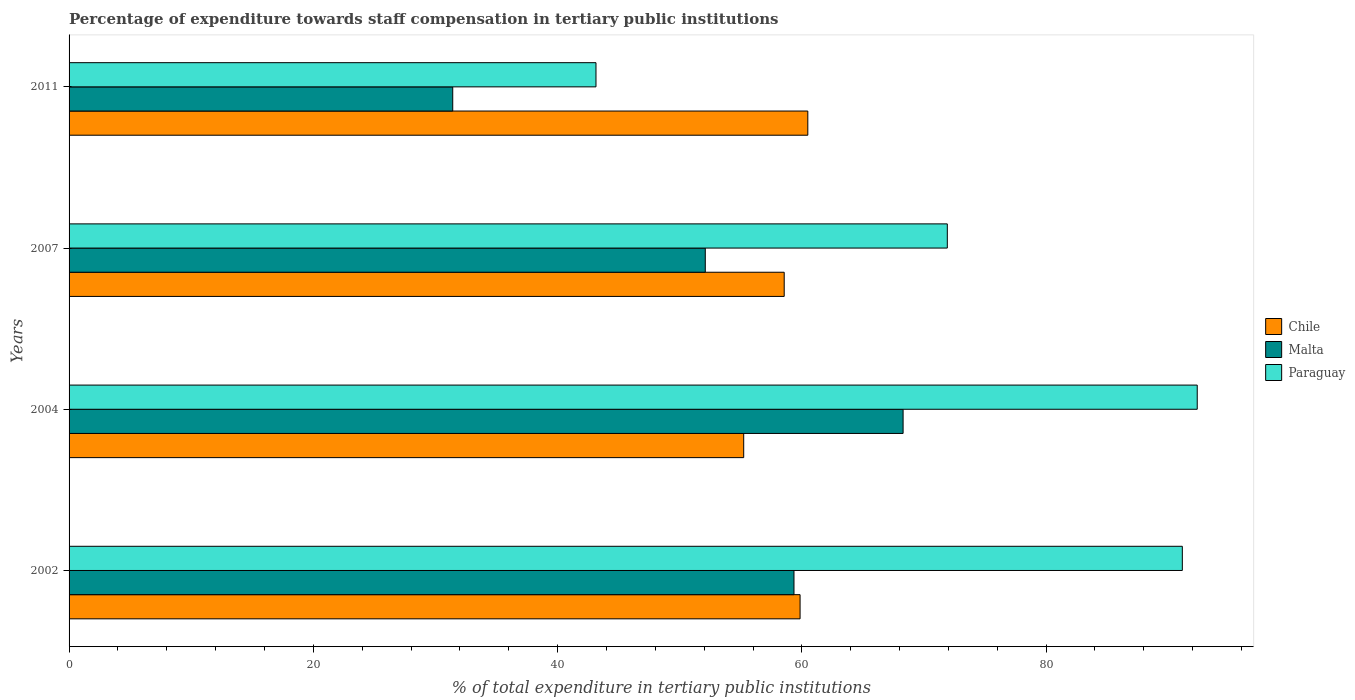How many different coloured bars are there?
Provide a succinct answer. 3. How many groups of bars are there?
Offer a very short reply. 4. Are the number of bars on each tick of the Y-axis equal?
Your response must be concise. Yes. How many bars are there on the 2nd tick from the bottom?
Keep it short and to the point. 3. What is the percentage of expenditure towards staff compensation in Chile in 2011?
Your response must be concise. 60.49. Across all years, what is the maximum percentage of expenditure towards staff compensation in Malta?
Give a very brief answer. 68.29. Across all years, what is the minimum percentage of expenditure towards staff compensation in Chile?
Your response must be concise. 55.24. In which year was the percentage of expenditure towards staff compensation in Paraguay maximum?
Ensure brevity in your answer.  2004. In which year was the percentage of expenditure towards staff compensation in Paraguay minimum?
Give a very brief answer. 2011. What is the total percentage of expenditure towards staff compensation in Chile in the graph?
Give a very brief answer. 234.14. What is the difference between the percentage of expenditure towards staff compensation in Paraguay in 2007 and that in 2011?
Your answer should be compact. 28.77. What is the difference between the percentage of expenditure towards staff compensation in Paraguay in 2004 and the percentage of expenditure towards staff compensation in Chile in 2007?
Offer a very short reply. 33.82. What is the average percentage of expenditure towards staff compensation in Paraguay per year?
Your answer should be compact. 74.64. In the year 2007, what is the difference between the percentage of expenditure towards staff compensation in Chile and percentage of expenditure towards staff compensation in Paraguay?
Make the answer very short. -13.35. What is the ratio of the percentage of expenditure towards staff compensation in Paraguay in 2002 to that in 2011?
Offer a terse response. 2.11. What is the difference between the highest and the second highest percentage of expenditure towards staff compensation in Paraguay?
Provide a short and direct response. 1.22. What is the difference between the highest and the lowest percentage of expenditure towards staff compensation in Malta?
Give a very brief answer. 36.88. In how many years, is the percentage of expenditure towards staff compensation in Paraguay greater than the average percentage of expenditure towards staff compensation in Paraguay taken over all years?
Give a very brief answer. 2. What does the 2nd bar from the top in 2004 represents?
Your answer should be compact. Malta. What does the 2nd bar from the bottom in 2011 represents?
Provide a succinct answer. Malta. Is it the case that in every year, the sum of the percentage of expenditure towards staff compensation in Chile and percentage of expenditure towards staff compensation in Paraguay is greater than the percentage of expenditure towards staff compensation in Malta?
Your response must be concise. Yes. How many bars are there?
Offer a terse response. 12. Are all the bars in the graph horizontal?
Your answer should be compact. Yes. How many years are there in the graph?
Your answer should be very brief. 4. What is the difference between two consecutive major ticks on the X-axis?
Keep it short and to the point. 20. Are the values on the major ticks of X-axis written in scientific E-notation?
Your answer should be very brief. No. Does the graph contain grids?
Your response must be concise. No. Where does the legend appear in the graph?
Your answer should be very brief. Center right. What is the title of the graph?
Offer a very short reply. Percentage of expenditure towards staff compensation in tertiary public institutions. Does "Japan" appear as one of the legend labels in the graph?
Your answer should be compact. No. What is the label or title of the X-axis?
Ensure brevity in your answer.  % of total expenditure in tertiary public institutions. What is the label or title of the Y-axis?
Your answer should be very brief. Years. What is the % of total expenditure in tertiary public institutions of Chile in 2002?
Provide a succinct answer. 59.85. What is the % of total expenditure in tertiary public institutions in Malta in 2002?
Offer a terse response. 59.36. What is the % of total expenditure in tertiary public institutions in Paraguay in 2002?
Make the answer very short. 91.15. What is the % of total expenditure in tertiary public institutions of Chile in 2004?
Your response must be concise. 55.24. What is the % of total expenditure in tertiary public institutions of Malta in 2004?
Your answer should be very brief. 68.29. What is the % of total expenditure in tertiary public institutions in Paraguay in 2004?
Offer a terse response. 92.37. What is the % of total expenditure in tertiary public institutions of Chile in 2007?
Offer a terse response. 58.56. What is the % of total expenditure in tertiary public institutions in Malta in 2007?
Offer a very short reply. 52.09. What is the % of total expenditure in tertiary public institutions of Paraguay in 2007?
Your answer should be compact. 71.91. What is the % of total expenditure in tertiary public institutions of Chile in 2011?
Your answer should be very brief. 60.49. What is the % of total expenditure in tertiary public institutions of Malta in 2011?
Provide a short and direct response. 31.41. What is the % of total expenditure in tertiary public institutions in Paraguay in 2011?
Give a very brief answer. 43.14. Across all years, what is the maximum % of total expenditure in tertiary public institutions of Chile?
Your response must be concise. 60.49. Across all years, what is the maximum % of total expenditure in tertiary public institutions of Malta?
Offer a very short reply. 68.29. Across all years, what is the maximum % of total expenditure in tertiary public institutions in Paraguay?
Your response must be concise. 92.37. Across all years, what is the minimum % of total expenditure in tertiary public institutions in Chile?
Provide a succinct answer. 55.24. Across all years, what is the minimum % of total expenditure in tertiary public institutions of Malta?
Ensure brevity in your answer.  31.41. Across all years, what is the minimum % of total expenditure in tertiary public institutions of Paraguay?
Give a very brief answer. 43.14. What is the total % of total expenditure in tertiary public institutions in Chile in the graph?
Your response must be concise. 234.14. What is the total % of total expenditure in tertiary public institutions in Malta in the graph?
Give a very brief answer. 211.15. What is the total % of total expenditure in tertiary public institutions in Paraguay in the graph?
Ensure brevity in your answer.  298.58. What is the difference between the % of total expenditure in tertiary public institutions in Chile in 2002 and that in 2004?
Provide a short and direct response. 4.62. What is the difference between the % of total expenditure in tertiary public institutions in Malta in 2002 and that in 2004?
Offer a terse response. -8.93. What is the difference between the % of total expenditure in tertiary public institutions of Paraguay in 2002 and that in 2004?
Keep it short and to the point. -1.22. What is the difference between the % of total expenditure in tertiary public institutions in Chile in 2002 and that in 2007?
Keep it short and to the point. 1.3. What is the difference between the % of total expenditure in tertiary public institutions in Malta in 2002 and that in 2007?
Give a very brief answer. 7.26. What is the difference between the % of total expenditure in tertiary public institutions in Paraguay in 2002 and that in 2007?
Provide a succinct answer. 19.24. What is the difference between the % of total expenditure in tertiary public institutions of Chile in 2002 and that in 2011?
Your response must be concise. -0.63. What is the difference between the % of total expenditure in tertiary public institutions of Malta in 2002 and that in 2011?
Your answer should be compact. 27.94. What is the difference between the % of total expenditure in tertiary public institutions in Paraguay in 2002 and that in 2011?
Your response must be concise. 48.01. What is the difference between the % of total expenditure in tertiary public institutions in Chile in 2004 and that in 2007?
Your answer should be compact. -3.32. What is the difference between the % of total expenditure in tertiary public institutions of Malta in 2004 and that in 2007?
Make the answer very short. 16.2. What is the difference between the % of total expenditure in tertiary public institutions in Paraguay in 2004 and that in 2007?
Keep it short and to the point. 20.46. What is the difference between the % of total expenditure in tertiary public institutions of Chile in 2004 and that in 2011?
Keep it short and to the point. -5.25. What is the difference between the % of total expenditure in tertiary public institutions in Malta in 2004 and that in 2011?
Provide a succinct answer. 36.88. What is the difference between the % of total expenditure in tertiary public institutions of Paraguay in 2004 and that in 2011?
Provide a succinct answer. 49.23. What is the difference between the % of total expenditure in tertiary public institutions of Chile in 2007 and that in 2011?
Provide a short and direct response. -1.93. What is the difference between the % of total expenditure in tertiary public institutions of Malta in 2007 and that in 2011?
Your answer should be very brief. 20.68. What is the difference between the % of total expenditure in tertiary public institutions of Paraguay in 2007 and that in 2011?
Keep it short and to the point. 28.77. What is the difference between the % of total expenditure in tertiary public institutions in Chile in 2002 and the % of total expenditure in tertiary public institutions in Malta in 2004?
Make the answer very short. -8.44. What is the difference between the % of total expenditure in tertiary public institutions in Chile in 2002 and the % of total expenditure in tertiary public institutions in Paraguay in 2004?
Your response must be concise. -32.52. What is the difference between the % of total expenditure in tertiary public institutions of Malta in 2002 and the % of total expenditure in tertiary public institutions of Paraguay in 2004?
Your answer should be compact. -33.02. What is the difference between the % of total expenditure in tertiary public institutions of Chile in 2002 and the % of total expenditure in tertiary public institutions of Malta in 2007?
Your answer should be compact. 7.76. What is the difference between the % of total expenditure in tertiary public institutions of Chile in 2002 and the % of total expenditure in tertiary public institutions of Paraguay in 2007?
Offer a very short reply. -12.06. What is the difference between the % of total expenditure in tertiary public institutions of Malta in 2002 and the % of total expenditure in tertiary public institutions of Paraguay in 2007?
Offer a terse response. -12.55. What is the difference between the % of total expenditure in tertiary public institutions in Chile in 2002 and the % of total expenditure in tertiary public institutions in Malta in 2011?
Ensure brevity in your answer.  28.44. What is the difference between the % of total expenditure in tertiary public institutions of Chile in 2002 and the % of total expenditure in tertiary public institutions of Paraguay in 2011?
Provide a short and direct response. 16.71. What is the difference between the % of total expenditure in tertiary public institutions of Malta in 2002 and the % of total expenditure in tertiary public institutions of Paraguay in 2011?
Your answer should be very brief. 16.21. What is the difference between the % of total expenditure in tertiary public institutions in Chile in 2004 and the % of total expenditure in tertiary public institutions in Malta in 2007?
Give a very brief answer. 3.15. What is the difference between the % of total expenditure in tertiary public institutions in Chile in 2004 and the % of total expenditure in tertiary public institutions in Paraguay in 2007?
Make the answer very short. -16.67. What is the difference between the % of total expenditure in tertiary public institutions in Malta in 2004 and the % of total expenditure in tertiary public institutions in Paraguay in 2007?
Provide a short and direct response. -3.62. What is the difference between the % of total expenditure in tertiary public institutions in Chile in 2004 and the % of total expenditure in tertiary public institutions in Malta in 2011?
Make the answer very short. 23.82. What is the difference between the % of total expenditure in tertiary public institutions of Chile in 2004 and the % of total expenditure in tertiary public institutions of Paraguay in 2011?
Give a very brief answer. 12.1. What is the difference between the % of total expenditure in tertiary public institutions in Malta in 2004 and the % of total expenditure in tertiary public institutions in Paraguay in 2011?
Provide a succinct answer. 25.15. What is the difference between the % of total expenditure in tertiary public institutions in Chile in 2007 and the % of total expenditure in tertiary public institutions in Malta in 2011?
Provide a succinct answer. 27.14. What is the difference between the % of total expenditure in tertiary public institutions in Chile in 2007 and the % of total expenditure in tertiary public institutions in Paraguay in 2011?
Your response must be concise. 15.41. What is the difference between the % of total expenditure in tertiary public institutions in Malta in 2007 and the % of total expenditure in tertiary public institutions in Paraguay in 2011?
Provide a succinct answer. 8.95. What is the average % of total expenditure in tertiary public institutions of Chile per year?
Keep it short and to the point. 58.53. What is the average % of total expenditure in tertiary public institutions of Malta per year?
Make the answer very short. 52.79. What is the average % of total expenditure in tertiary public institutions in Paraguay per year?
Offer a terse response. 74.64. In the year 2002, what is the difference between the % of total expenditure in tertiary public institutions in Chile and % of total expenditure in tertiary public institutions in Malta?
Keep it short and to the point. 0.5. In the year 2002, what is the difference between the % of total expenditure in tertiary public institutions of Chile and % of total expenditure in tertiary public institutions of Paraguay?
Offer a very short reply. -31.3. In the year 2002, what is the difference between the % of total expenditure in tertiary public institutions in Malta and % of total expenditure in tertiary public institutions in Paraguay?
Provide a short and direct response. -31.8. In the year 2004, what is the difference between the % of total expenditure in tertiary public institutions of Chile and % of total expenditure in tertiary public institutions of Malta?
Offer a very short reply. -13.05. In the year 2004, what is the difference between the % of total expenditure in tertiary public institutions of Chile and % of total expenditure in tertiary public institutions of Paraguay?
Your answer should be very brief. -37.13. In the year 2004, what is the difference between the % of total expenditure in tertiary public institutions of Malta and % of total expenditure in tertiary public institutions of Paraguay?
Give a very brief answer. -24.08. In the year 2007, what is the difference between the % of total expenditure in tertiary public institutions of Chile and % of total expenditure in tertiary public institutions of Malta?
Your answer should be very brief. 6.46. In the year 2007, what is the difference between the % of total expenditure in tertiary public institutions in Chile and % of total expenditure in tertiary public institutions in Paraguay?
Offer a very short reply. -13.35. In the year 2007, what is the difference between the % of total expenditure in tertiary public institutions of Malta and % of total expenditure in tertiary public institutions of Paraguay?
Offer a terse response. -19.82. In the year 2011, what is the difference between the % of total expenditure in tertiary public institutions of Chile and % of total expenditure in tertiary public institutions of Malta?
Provide a short and direct response. 29.07. In the year 2011, what is the difference between the % of total expenditure in tertiary public institutions in Chile and % of total expenditure in tertiary public institutions in Paraguay?
Your answer should be very brief. 17.34. In the year 2011, what is the difference between the % of total expenditure in tertiary public institutions in Malta and % of total expenditure in tertiary public institutions in Paraguay?
Your answer should be compact. -11.73. What is the ratio of the % of total expenditure in tertiary public institutions in Chile in 2002 to that in 2004?
Provide a succinct answer. 1.08. What is the ratio of the % of total expenditure in tertiary public institutions in Malta in 2002 to that in 2004?
Provide a short and direct response. 0.87. What is the ratio of the % of total expenditure in tertiary public institutions in Chile in 2002 to that in 2007?
Your answer should be compact. 1.02. What is the ratio of the % of total expenditure in tertiary public institutions of Malta in 2002 to that in 2007?
Make the answer very short. 1.14. What is the ratio of the % of total expenditure in tertiary public institutions in Paraguay in 2002 to that in 2007?
Offer a very short reply. 1.27. What is the ratio of the % of total expenditure in tertiary public institutions in Malta in 2002 to that in 2011?
Keep it short and to the point. 1.89. What is the ratio of the % of total expenditure in tertiary public institutions in Paraguay in 2002 to that in 2011?
Your answer should be very brief. 2.11. What is the ratio of the % of total expenditure in tertiary public institutions in Chile in 2004 to that in 2007?
Your answer should be compact. 0.94. What is the ratio of the % of total expenditure in tertiary public institutions in Malta in 2004 to that in 2007?
Give a very brief answer. 1.31. What is the ratio of the % of total expenditure in tertiary public institutions in Paraguay in 2004 to that in 2007?
Give a very brief answer. 1.28. What is the ratio of the % of total expenditure in tertiary public institutions of Chile in 2004 to that in 2011?
Offer a very short reply. 0.91. What is the ratio of the % of total expenditure in tertiary public institutions in Malta in 2004 to that in 2011?
Your answer should be very brief. 2.17. What is the ratio of the % of total expenditure in tertiary public institutions of Paraguay in 2004 to that in 2011?
Make the answer very short. 2.14. What is the ratio of the % of total expenditure in tertiary public institutions of Chile in 2007 to that in 2011?
Provide a short and direct response. 0.97. What is the ratio of the % of total expenditure in tertiary public institutions of Malta in 2007 to that in 2011?
Give a very brief answer. 1.66. What is the ratio of the % of total expenditure in tertiary public institutions of Paraguay in 2007 to that in 2011?
Provide a succinct answer. 1.67. What is the difference between the highest and the second highest % of total expenditure in tertiary public institutions of Chile?
Provide a short and direct response. 0.63. What is the difference between the highest and the second highest % of total expenditure in tertiary public institutions of Malta?
Offer a very short reply. 8.93. What is the difference between the highest and the second highest % of total expenditure in tertiary public institutions of Paraguay?
Ensure brevity in your answer.  1.22. What is the difference between the highest and the lowest % of total expenditure in tertiary public institutions in Chile?
Give a very brief answer. 5.25. What is the difference between the highest and the lowest % of total expenditure in tertiary public institutions in Malta?
Your response must be concise. 36.88. What is the difference between the highest and the lowest % of total expenditure in tertiary public institutions in Paraguay?
Keep it short and to the point. 49.23. 